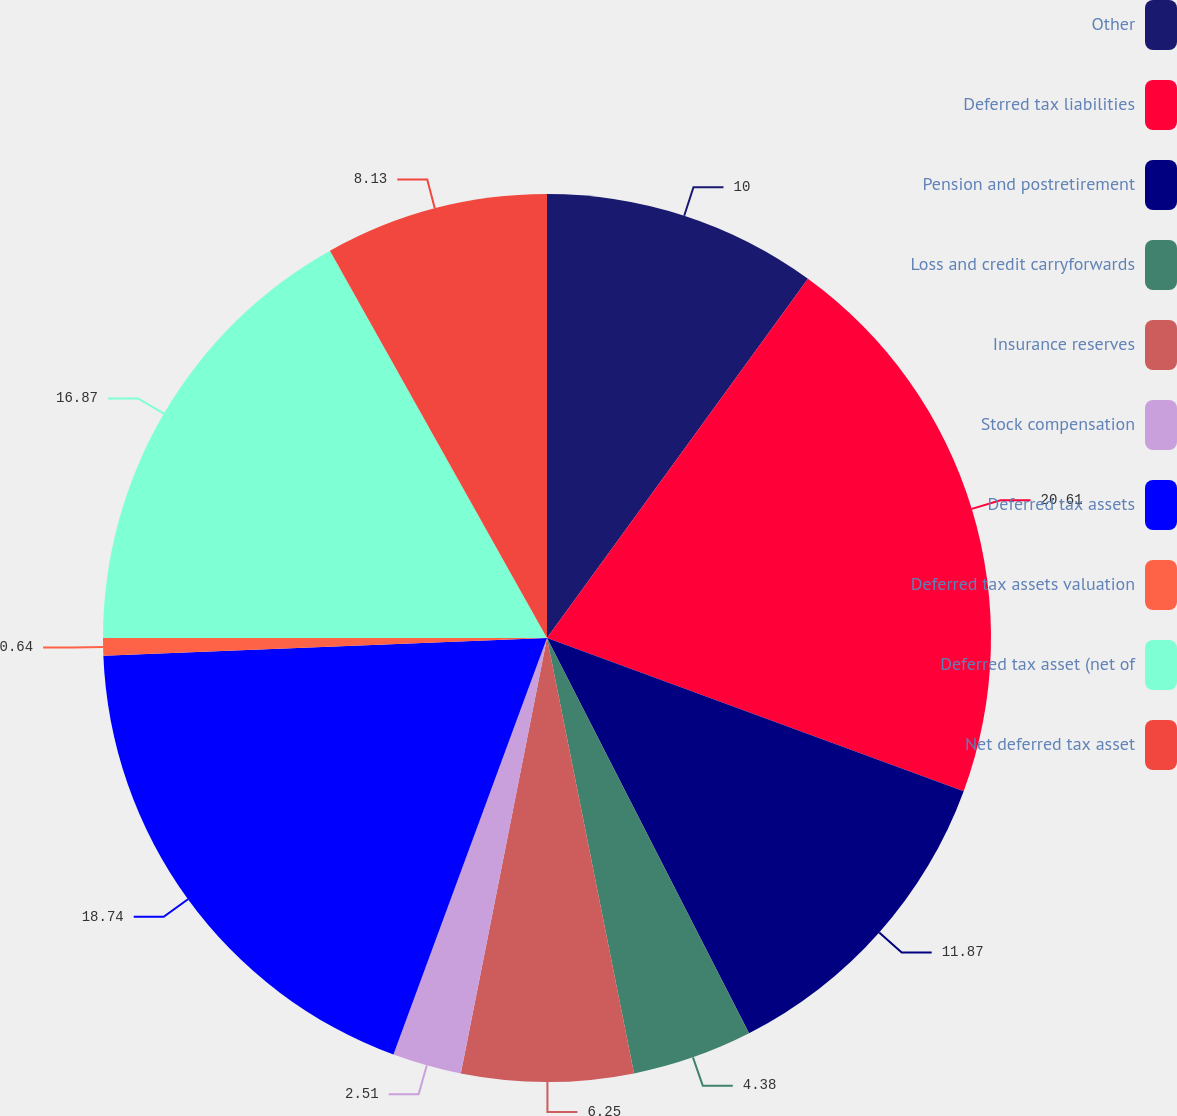<chart> <loc_0><loc_0><loc_500><loc_500><pie_chart><fcel>Other<fcel>Deferred tax liabilities<fcel>Pension and postretirement<fcel>Loss and credit carryforwards<fcel>Insurance reserves<fcel>Stock compensation<fcel>Deferred tax assets<fcel>Deferred tax assets valuation<fcel>Deferred tax asset (net of<fcel>Net deferred tax asset<nl><fcel>10.0%<fcel>20.61%<fcel>11.87%<fcel>4.38%<fcel>6.25%<fcel>2.51%<fcel>18.74%<fcel>0.64%<fcel>16.87%<fcel>8.13%<nl></chart> 